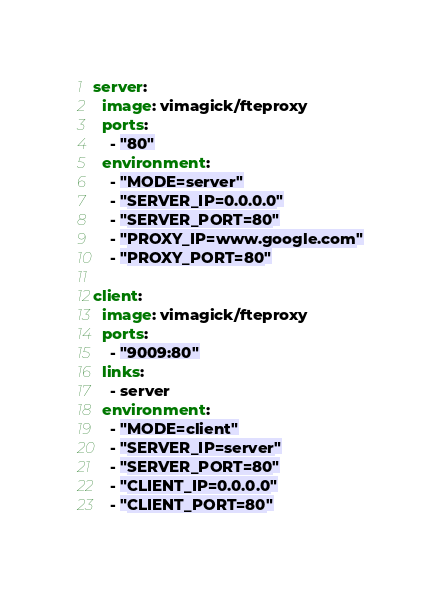<code> <loc_0><loc_0><loc_500><loc_500><_YAML_>server:
  image: vimagick/fteproxy
  ports:
    - "80"
  environment:
    - "MODE=server"
    - "SERVER_IP=0.0.0.0"
    - "SERVER_PORT=80"
    - "PROXY_IP=www.google.com"
    - "PROXY_PORT=80"

client:
  image: vimagick/fteproxy
  ports:
    - "9009:80"
  links:
    - server
  environment:
    - "MODE=client"
    - "SERVER_IP=server"
    - "SERVER_PORT=80"
    - "CLIENT_IP=0.0.0.0"
    - "CLIENT_PORT=80"
</code> 